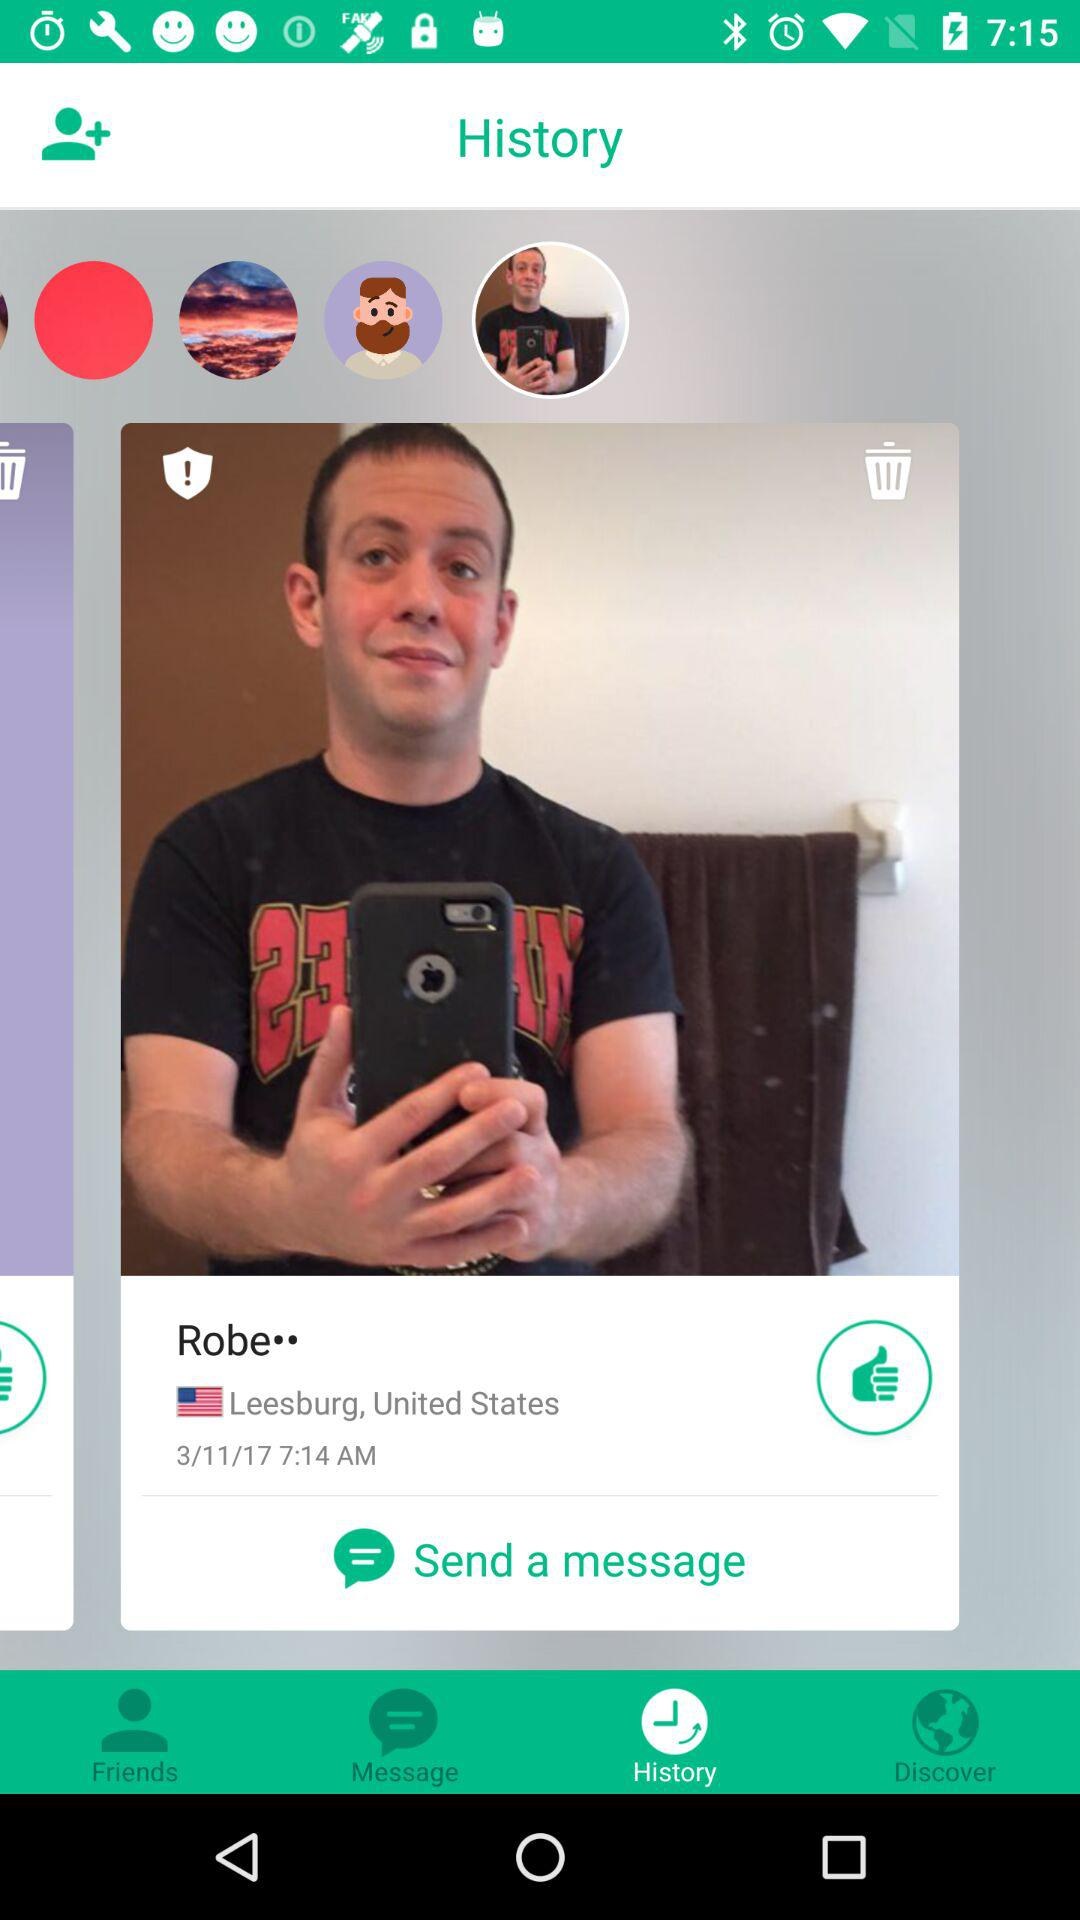What is the location of Robe? The location is Leesburg, United States. 